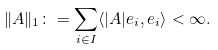Convert formula to latex. <formula><loc_0><loc_0><loc_500><loc_500>\| A \| _ { 1 } \colon = \sum _ { i \in I } \langle | A | e _ { i } , e _ { i } \rangle < \infty .</formula> 